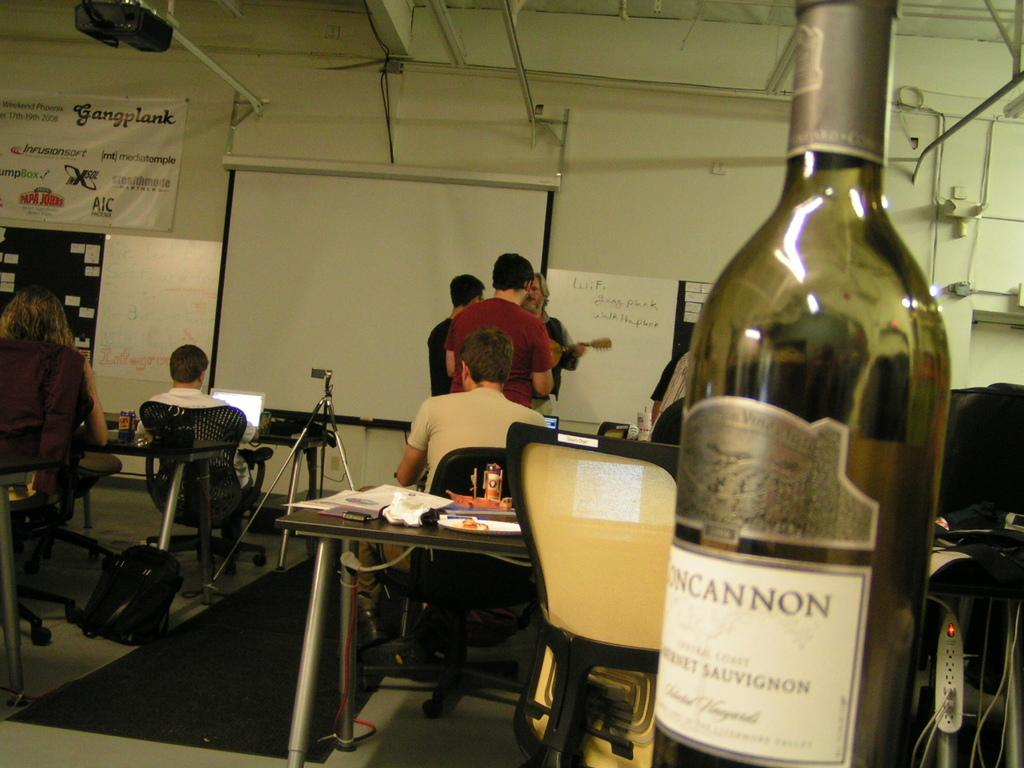Provide a one-sentence caption for the provided image. People are in a classroom with a banner that says "Gangplank". 